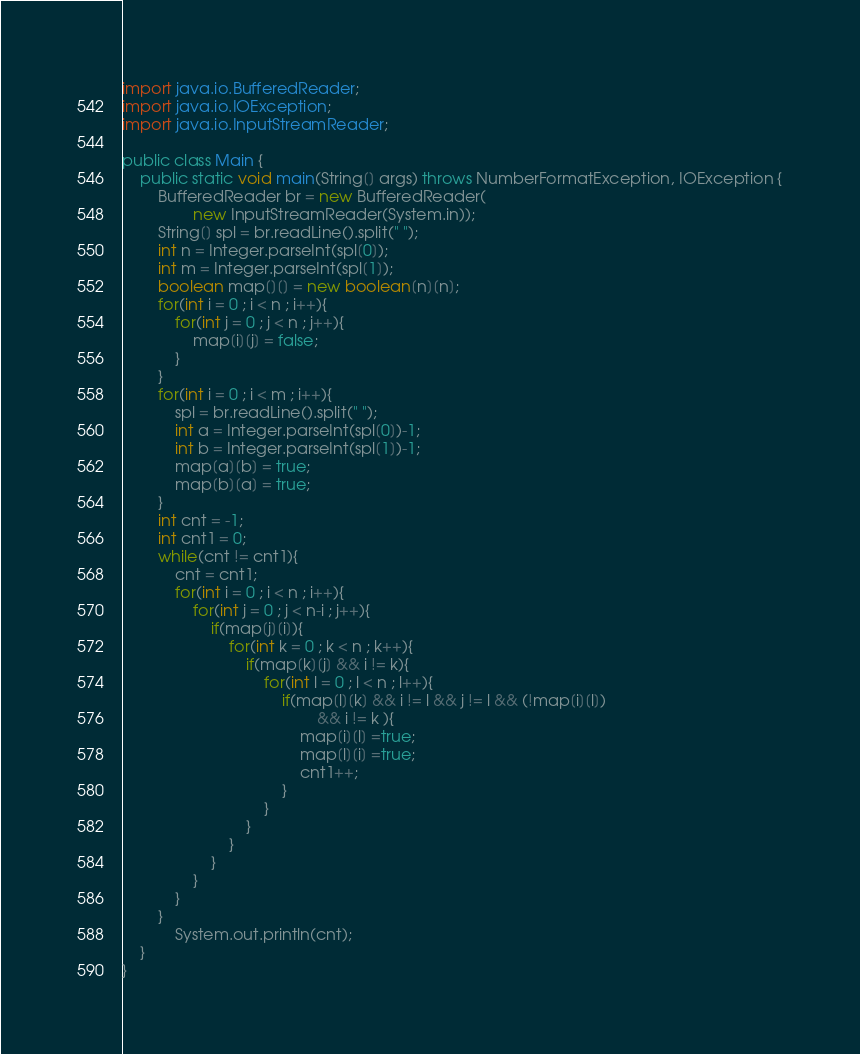<code> <loc_0><loc_0><loc_500><loc_500><_Java_>import java.io.BufferedReader;
import java.io.IOException;
import java.io.InputStreamReader;

public class Main {
	public static void main(String[] args) throws NumberFormatException, IOException {
		BufferedReader br = new BufferedReader(
				new InputStreamReader(System.in));
		String[] spl = br.readLine().split(" ");
		int n = Integer.parseInt(spl[0]);
		int m = Integer.parseInt(spl[1]);
		boolean map[][] = new boolean[n][n];
		for(int i = 0 ; i < n ; i++){
			for(int j = 0 ; j < n ; j++){
				map[i][j] = false;
			}
		}
		for(int i = 0 ; i < m ; i++){
			spl = br.readLine().split(" ");
			int a = Integer.parseInt(spl[0])-1;
			int b = Integer.parseInt(spl[1])-1;
			map[a][b] = true;
			map[b][a] = true;
		}
		int cnt = -1;
		int cnt1 = 0;
		while(cnt != cnt1){
			cnt = cnt1;
			for(int i = 0 ; i < n ; i++){
				for(int j = 0 ; j < n-i ; j++){
					if(map[j][i]){
						for(int k = 0 ; k < n ; k++){
							if(map[k][j] && i != k){
								for(int l = 0 ; l < n ; l++){
									if(map[l][k] && i != l && j != l && (!map[i][l])
											&& i != k ){
										map[i][l] =true;
										map[l][i] =true;
										cnt1++;
									}
								}
							}
						}
					}
				}
			}
		}
			System.out.println(cnt);
	}
}
</code> 